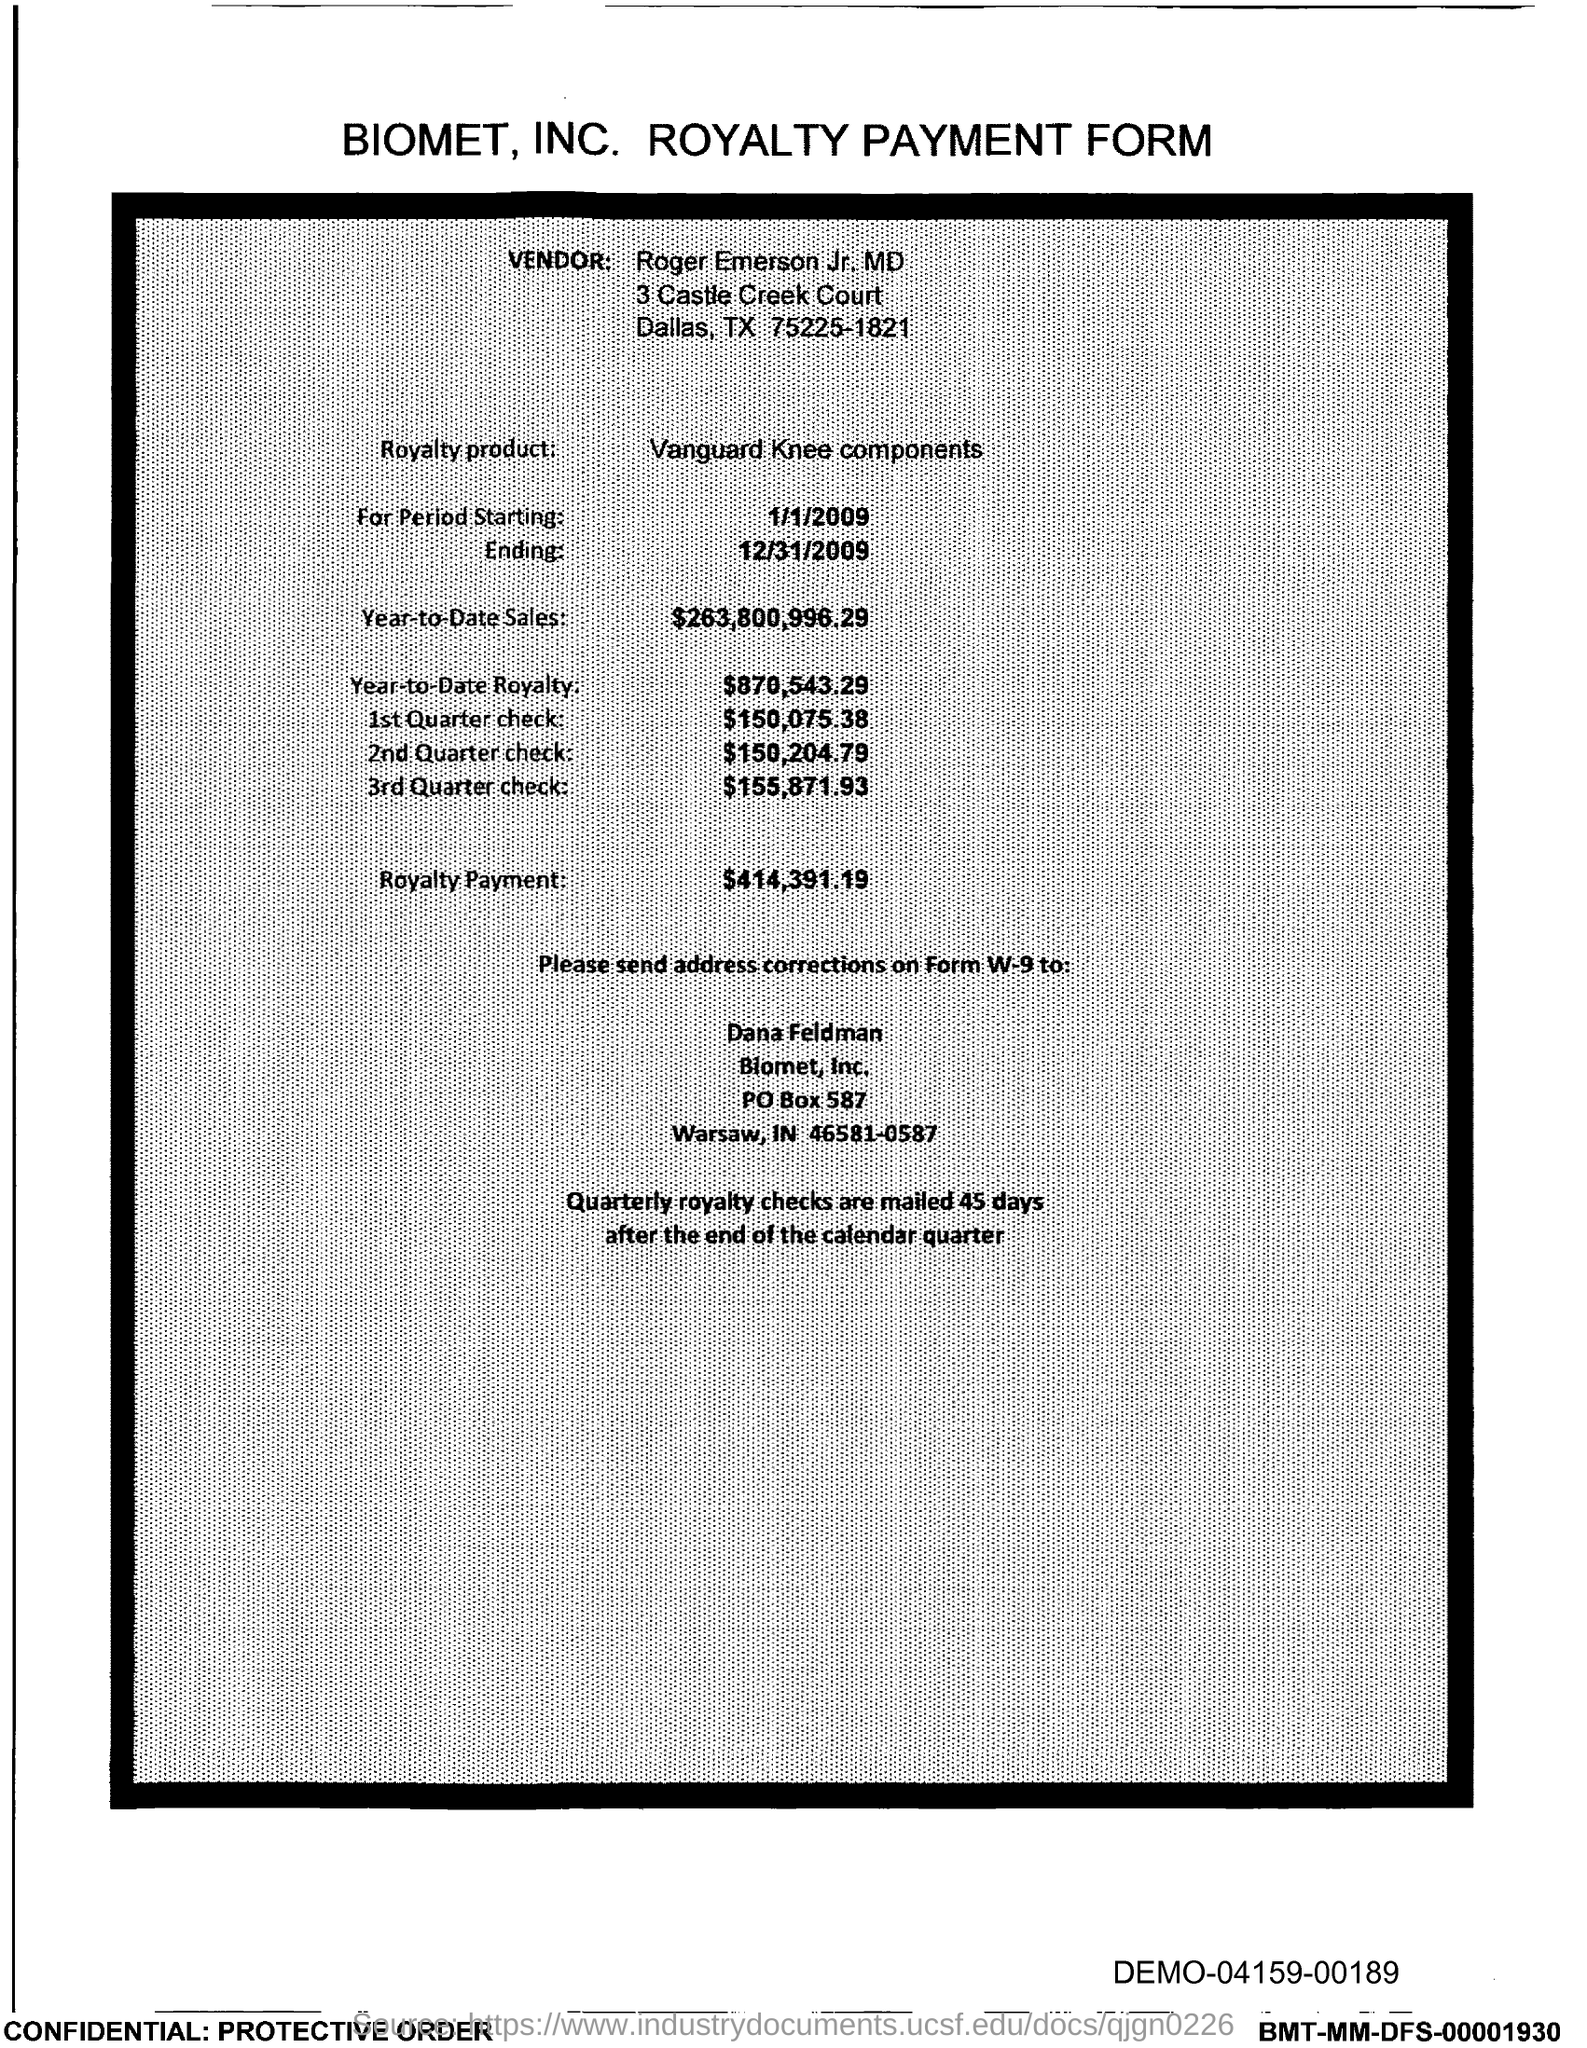Mention a couple of crucial points in this snapshot. As of today, the year-to-date sales of the royalty product are 263,800,996.29. The royalty product in the form of Vanguard Knee components has been provided. The amount of the third quarter check given in the form is $155,871.93. This is the royalty payment form of the company known as Biomet. The year-to-date royalty for the product is $870,543.29. 